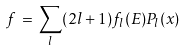<formula> <loc_0><loc_0><loc_500><loc_500>f \, = \, \sum _ { l } ( 2 l + 1 ) f _ { l } ( E ) P _ { l } ( x )</formula> 